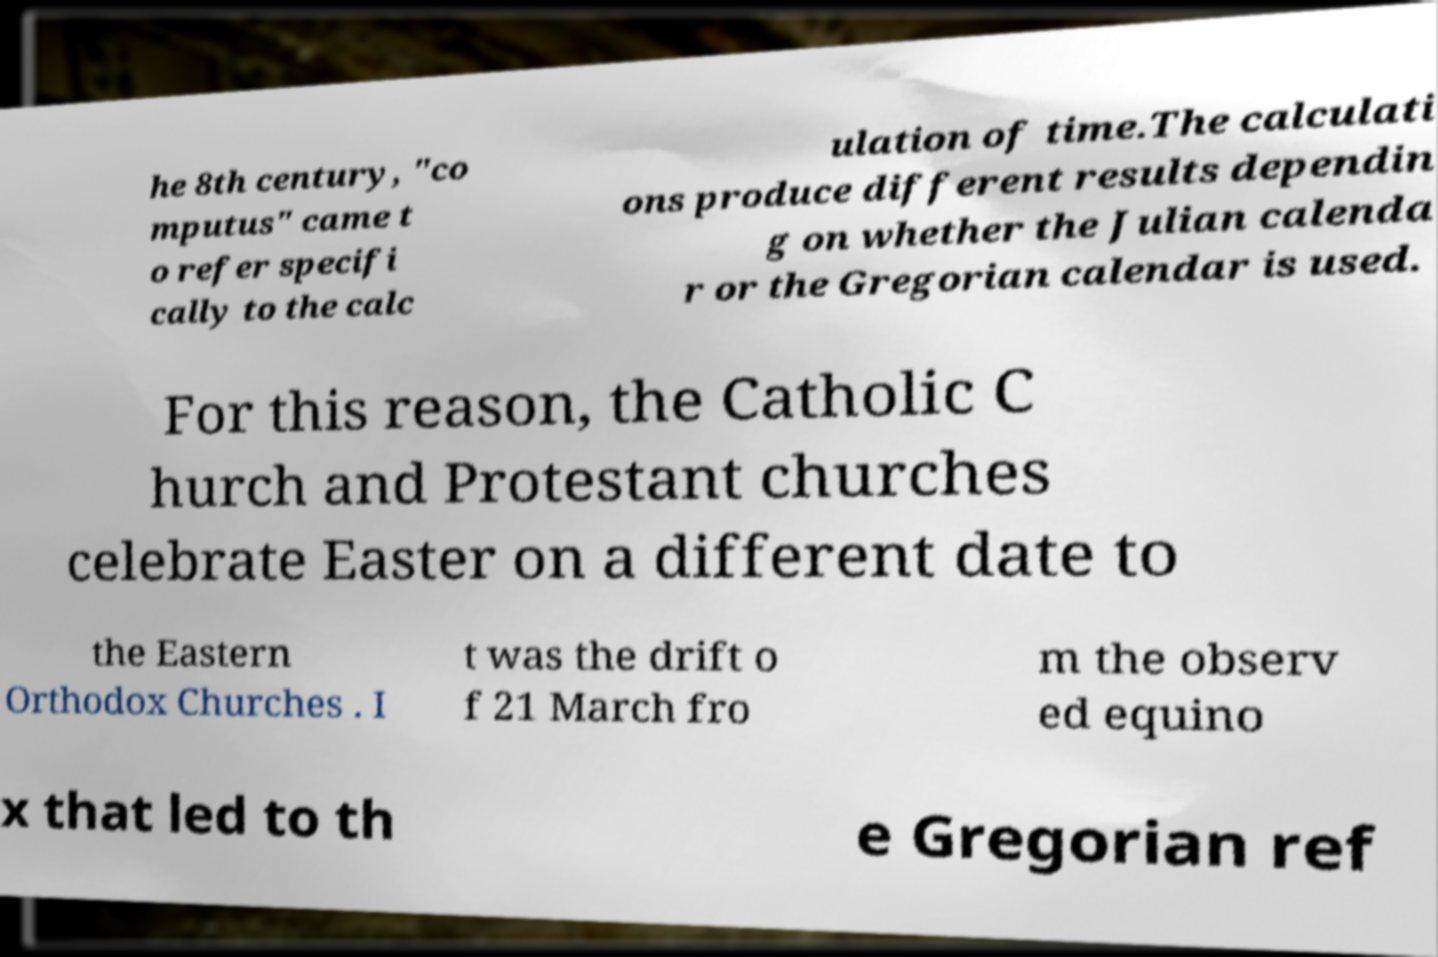Can you accurately transcribe the text from the provided image for me? he 8th century, "co mputus" came t o refer specifi cally to the calc ulation of time.The calculati ons produce different results dependin g on whether the Julian calenda r or the Gregorian calendar is used. For this reason, the Catholic C hurch and Protestant churches celebrate Easter on a different date to the Eastern Orthodox Churches . I t was the drift o f 21 March fro m the observ ed equino x that led to th e Gregorian ref 